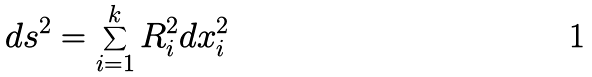<formula> <loc_0><loc_0><loc_500><loc_500>d s ^ { 2 } = \sum _ { i = 1 } ^ { k } R _ { i } ^ { 2 } d x _ { i } ^ { 2 }</formula> 